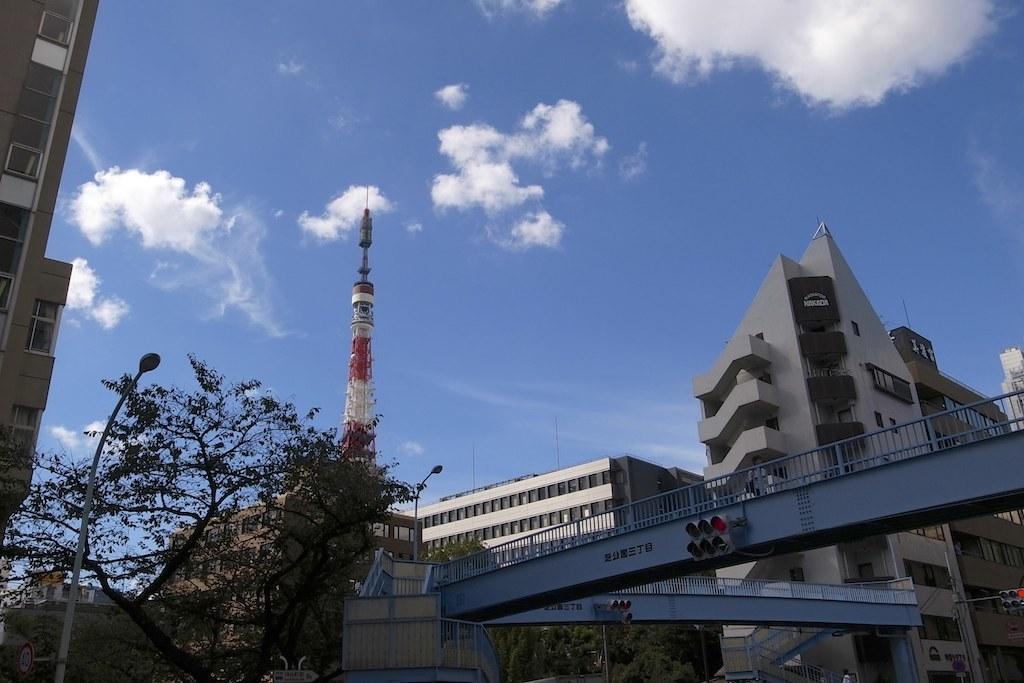Describe this image in one or two sentences. In this image I can see a tower in the center of the image. Some buildings on the left, right and in the center of the image. I can see a bridge with traffic lights on the right side. I can see a tree and light poles on the left side. At the top of the image I can see the sky.  